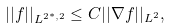Convert formula to latex. <formula><loc_0><loc_0><loc_500><loc_500>| | f | | _ { L ^ { 2 ^ { * } , 2 } } \leq C | | \nabla f | | _ { L ^ { 2 } } ,</formula> 